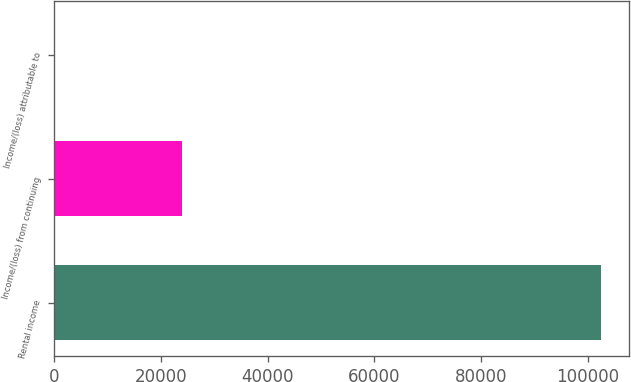Convert chart. <chart><loc_0><loc_0><loc_500><loc_500><bar_chart><fcel>Rental income<fcel>Income/(loss) from continuing<fcel>Income/(loss) attributable to<nl><fcel>102605<fcel>23917.5<fcel>0.07<nl></chart> 